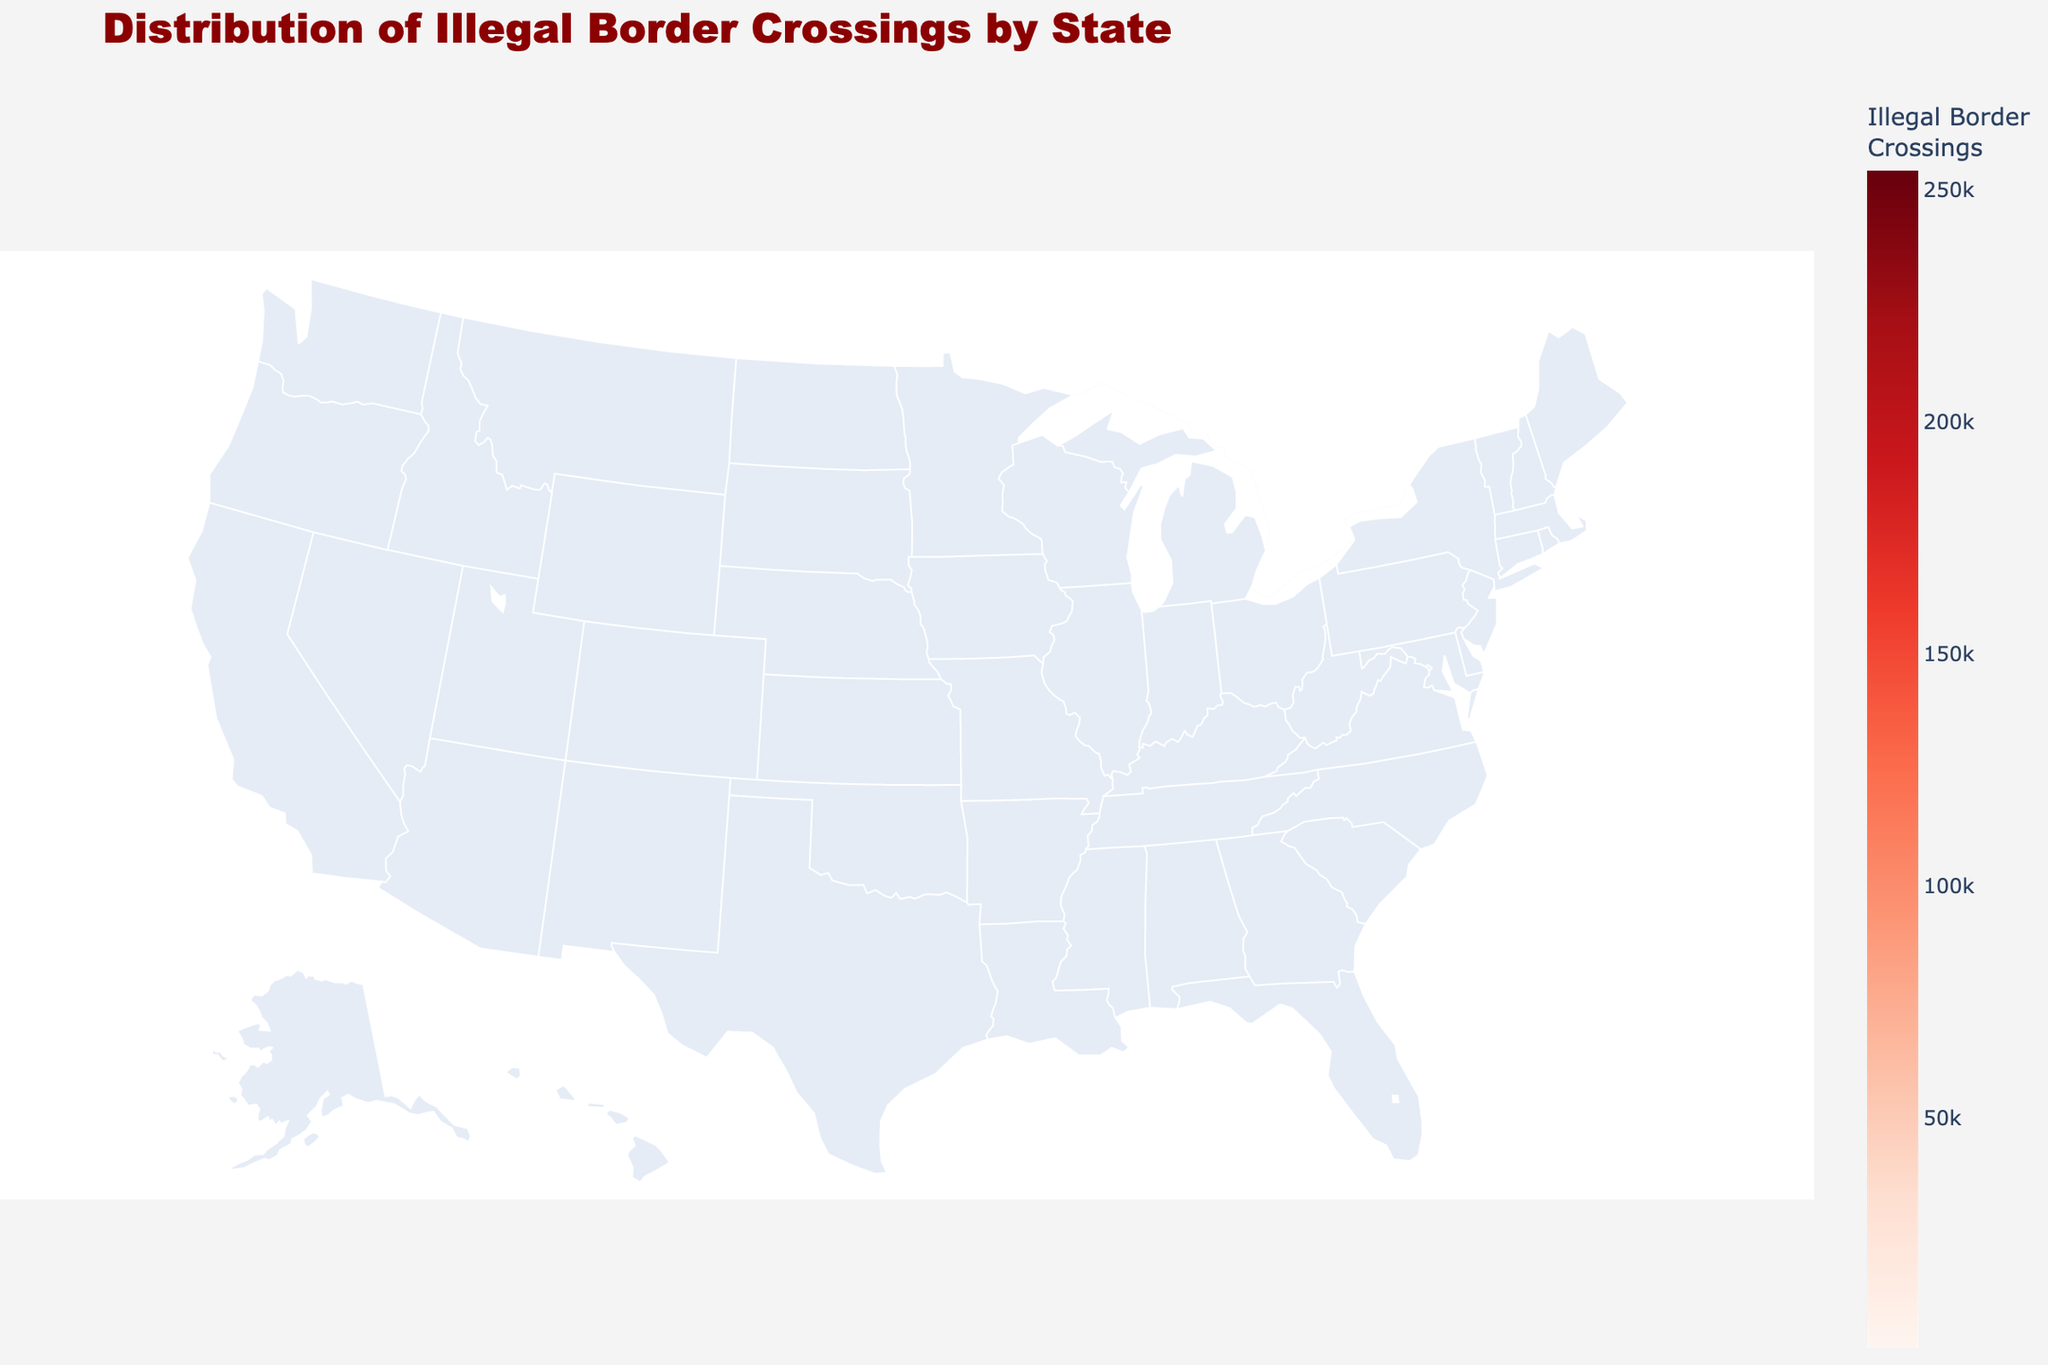What's the title of the figure? The title is displayed at the top of the figure, stating its subject matter. It reads "Distribution of Illegal Border Crossings by State."
Answer: Distribution of Illegal Border Crossings by State Which state has the highest number of illegal border crossings? The figure uses color intensity to represent the number of illegal border crossings. The darkest red state has the highest value, which is Texas.
Answer: Texas How many illegal border crossings are there in California? Hovering over California in the interactive choropleth map or referring to the color key reveals that California has 72,000 illegal border crossings.
Answer: 72,000 What’s the difference in illegal border crossings between Texas and Arizona? Texas has 254,000 illegal border crossings, while Arizona has 128,000. The difference is calculated as 254,000 - 128,000.
Answer: 126,000 Which regions show the least number of illegal border crossings? The lighter shades of red indicate fewer illegal crossings. States like Alaska and Vermont, colored very lightly, have the fewest crossings. Examining the data, Alaska and Vermont have 600 and 900 crossings, respectively.
Answer: Alaska and Vermont What is the approximate total number of illegal border crossings for the top three states? By adding the crossings for Texas (254,000), Arizona (128,000), and California (72,000), we get 254000 + 128000 + 72000.
Answer: 454,000 How do New York and Florida compare in terms of illegal border crossings? By comparing the hover information or shades, we find New York has 3,700 crossings while Florida has 16,000 crossings. Florida has significantly more crossings than New York.
Answer: Florida has more What is the average number of illegal border crossings among all listed states? Adding up all values and dividing by the number of states gives the average. The sum is 519,000 divided by 14 states.
Answer: 37,071 How does California rank in terms of illegal border crossings compared to other states? California, with 72,000 crossings, is third after Texas and Arizona based on the color intensity in the map and data.
Answer: Third Are there any states with less than 5,000 illegal border crossings? Examining the data and lighter colors on the figure, states such as Washington, Michigan, New York, Montana, North Dakota, Maine, Vermont, and Alaska each have fewer than 5,000 crossings.
Answer: Yes 